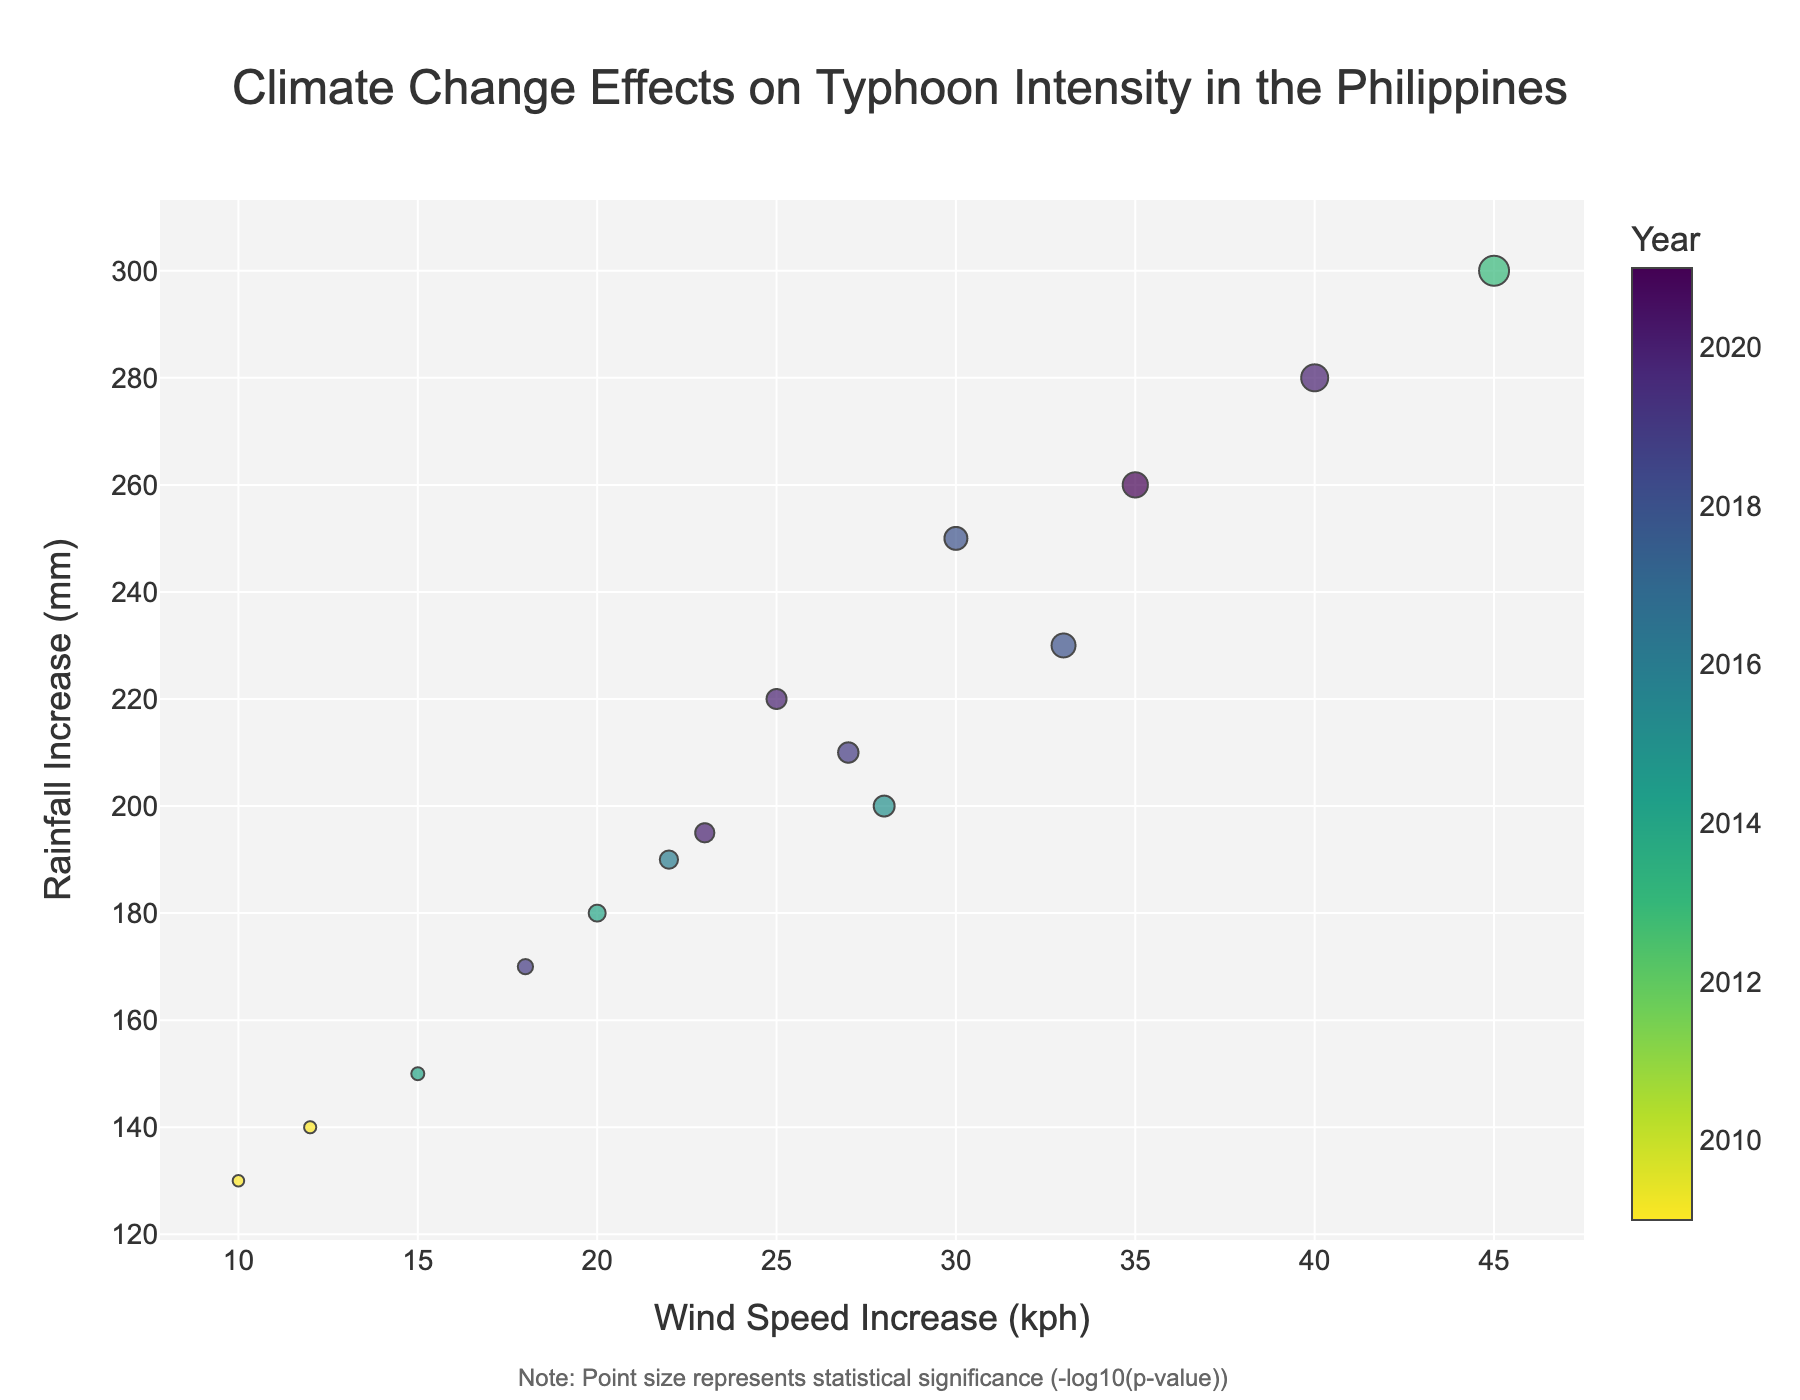What is the title of the figure? The title of the figure is typically found at the top of the plot, providing a brief description of what the plot is about. In this case, it is explicitly stated in the code.
Answer: Climate Change Effects on Typhoon Intensity in the Philippines How many data points are shown in the plot? The number of data points in the plot is equivalent to the number of typhoons listed in the provided data. Count the rows in the dataset to find this.
Answer: 15 What does the color of the data points represent? According to the code, color represents the year in which each typhoon occurred. This information is shown in the hover template and color bar.
Answer: Year Which typhoon had the highest wind speed increase? To determine this, identify the data point with the highest 'wind speed increase (kph)' value in the plot. Yolanda shows the largest increase in the data list.
Answer: Yolanda What is the significance level of typhoon Ulysses? The significance level is represented by the p-value in the data. According to the hover template, the -log10(p-value) determines the point size. For Ulysses, we need to look for its p-value.
Answer: 0.01 Which year had the most intense typhoons in terms of wind speed and rainfall? Compare the years through the color of the data points with the highest values on the x and y axes. Multiple 2020 typhoons (Rolly and Ulysses) had high wind speed and rainfall increases.
Answer: 2020 What does the size of the data points indicate? Point size is adjusted based on the statistical significance of the increase in wind speed and rainfall, represented by -log10(p-value). Larger points indicate higher significance. This is explicitly noted in the figure's annotation.
Answer: Statistical significance Which typhoon had the smallest increase in wind speed? Identify the data point located furthest to the left on the x-axis. According to the data, Pepeng has the smallest wind speed increase of 10 kph.
Answer: Pepeng Which had more rainfall increase, Rolly or Odette? Compare the rainfall increase (y-axis) values for the typhoons Rolly and Odette. The plot will show that Rolly has a higher rainfall increase.
Answer: Rolly How does typhoon Yolanda compare to Ondoy in terms of wind speed and rainfall increase? Compare the positions of Yolanda and Ondoy on the plot. Yolanda has significantly higher wind speed and rainfall increase than Ondoy, shown by its location far to the right and higher up.
Answer: Yolanda has higher increases for both 